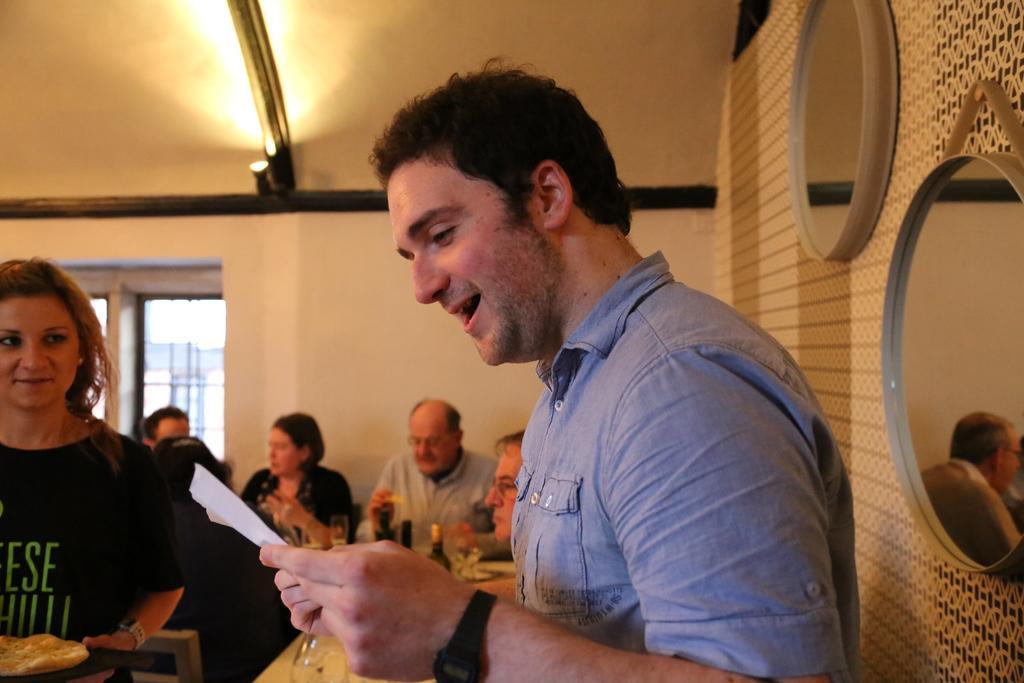Could you give a brief overview of what you see in this image? In this picture we can see a man holding a paper. On the left side of the image, there is a woman holding a food on an object. Behind the two persons, there are people, a window, a wall and light. On the right side of the image, there are two mirrors attached to the wall and one of the mirror we can see the reflection of a man and a wall. 